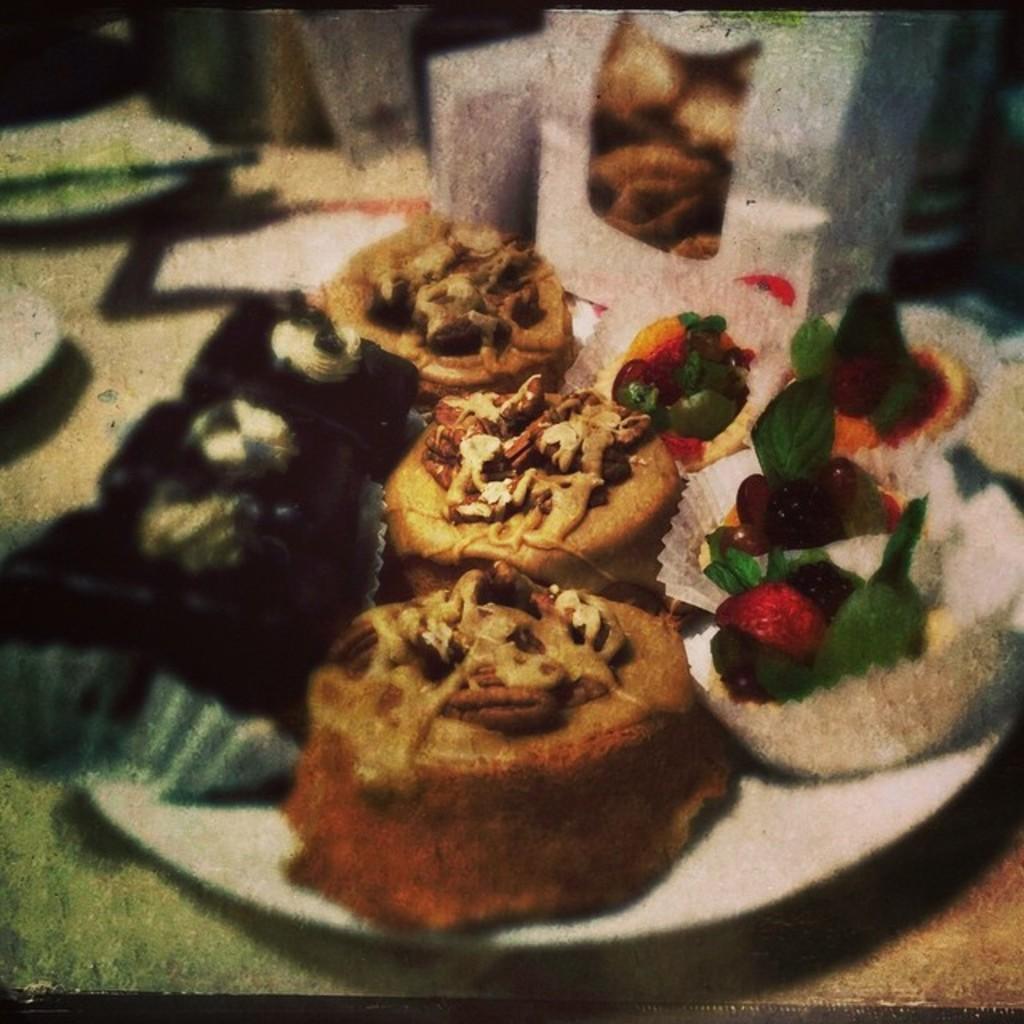Describe this image in one or two sentences. In this image I can see food items in a plate and glasses kept on the table. This image is taken may be in a room. 